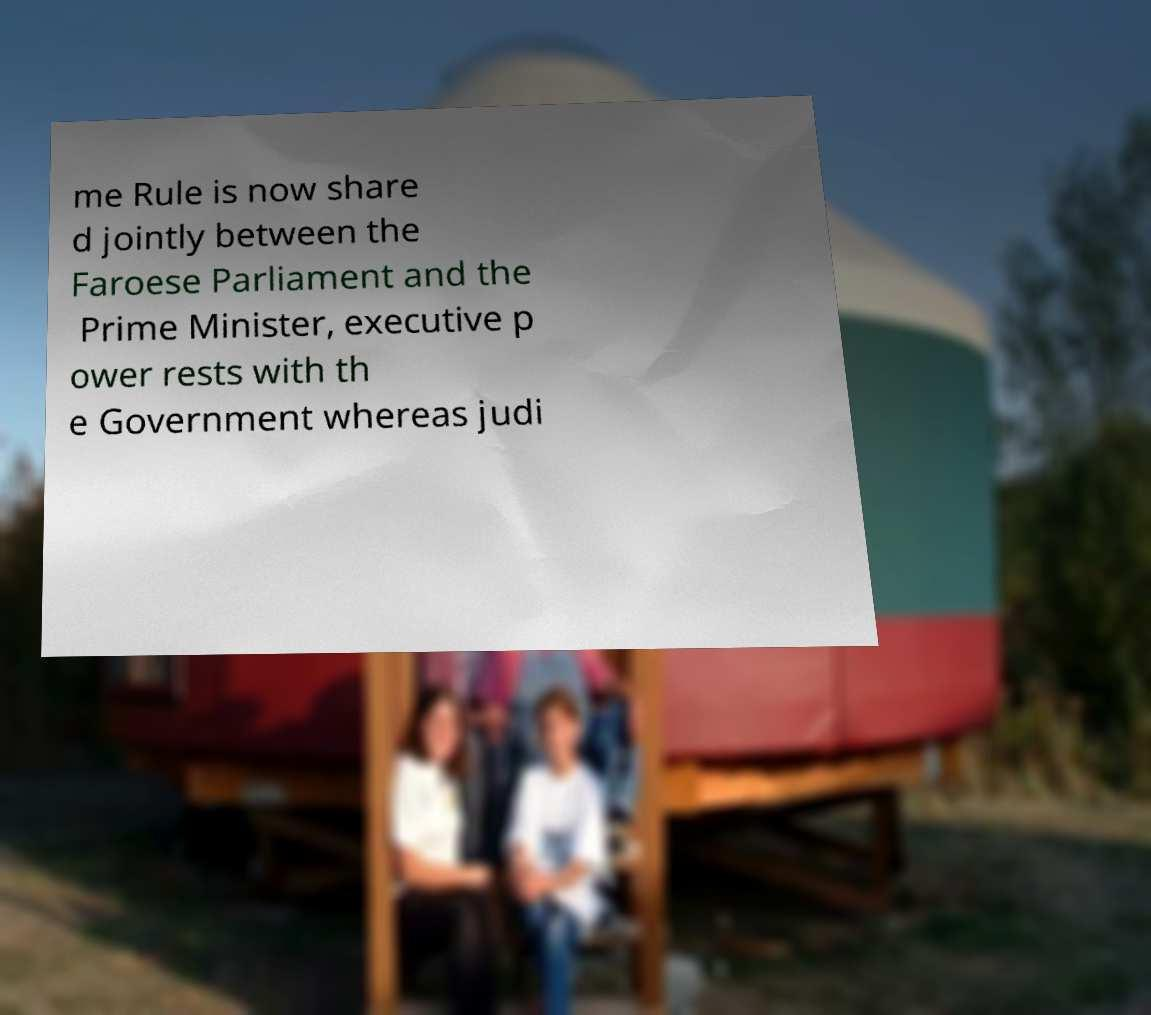Can you read and provide the text displayed in the image?This photo seems to have some interesting text. Can you extract and type it out for me? me Rule is now share d jointly between the Faroese Parliament and the Prime Minister, executive p ower rests with th e Government whereas judi 